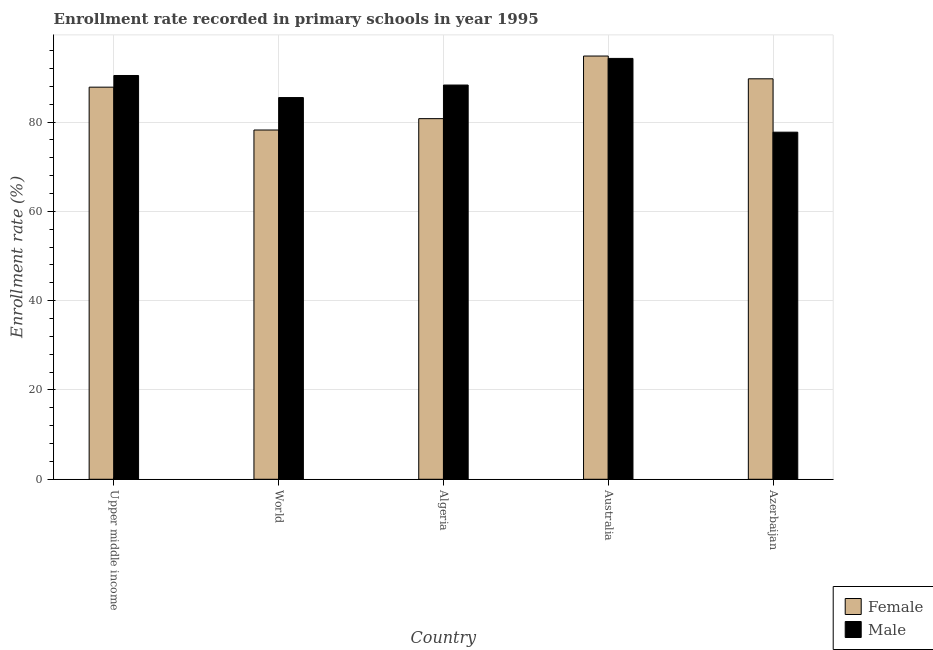How many different coloured bars are there?
Your answer should be very brief. 2. Are the number of bars per tick equal to the number of legend labels?
Give a very brief answer. Yes. Are the number of bars on each tick of the X-axis equal?
Your answer should be very brief. Yes. How many bars are there on the 4th tick from the left?
Ensure brevity in your answer.  2. How many bars are there on the 4th tick from the right?
Provide a succinct answer. 2. What is the label of the 5th group of bars from the left?
Ensure brevity in your answer.  Azerbaijan. In how many cases, is the number of bars for a given country not equal to the number of legend labels?
Ensure brevity in your answer.  0. What is the enrollment rate of female students in World?
Keep it short and to the point. 78.23. Across all countries, what is the maximum enrollment rate of female students?
Provide a short and direct response. 94.8. Across all countries, what is the minimum enrollment rate of female students?
Make the answer very short. 78.23. In which country was the enrollment rate of male students maximum?
Ensure brevity in your answer.  Australia. What is the total enrollment rate of male students in the graph?
Offer a terse response. 436.26. What is the difference between the enrollment rate of female students in Australia and that in Azerbaijan?
Ensure brevity in your answer.  5.1. What is the difference between the enrollment rate of male students in Australia and the enrollment rate of female students in Algeria?
Give a very brief answer. 13.49. What is the average enrollment rate of female students per country?
Give a very brief answer. 86.27. What is the difference between the enrollment rate of female students and enrollment rate of male students in Australia?
Provide a succinct answer. 0.53. In how many countries, is the enrollment rate of female students greater than 16 %?
Provide a succinct answer. 5. What is the ratio of the enrollment rate of male students in Azerbaijan to that in World?
Provide a succinct answer. 0.91. Is the enrollment rate of female students in Azerbaijan less than that in World?
Provide a succinct answer. No. What is the difference between the highest and the second highest enrollment rate of female students?
Your answer should be compact. 5.1. What is the difference between the highest and the lowest enrollment rate of male students?
Give a very brief answer. 16.52. What does the 2nd bar from the right in Upper middle income represents?
Ensure brevity in your answer.  Female. How many bars are there?
Give a very brief answer. 10. Are all the bars in the graph horizontal?
Offer a terse response. No. What is the difference between two consecutive major ticks on the Y-axis?
Keep it short and to the point. 20. Are the values on the major ticks of Y-axis written in scientific E-notation?
Your response must be concise. No. Does the graph contain any zero values?
Make the answer very short. No. Where does the legend appear in the graph?
Ensure brevity in your answer.  Bottom right. How many legend labels are there?
Keep it short and to the point. 2. How are the legend labels stacked?
Provide a succinct answer. Vertical. What is the title of the graph?
Your response must be concise. Enrollment rate recorded in primary schools in year 1995. Does "constant 2005 US$" appear as one of the legend labels in the graph?
Give a very brief answer. No. What is the label or title of the X-axis?
Provide a succinct answer. Country. What is the label or title of the Y-axis?
Offer a terse response. Enrollment rate (%). What is the Enrollment rate (%) of Female in Upper middle income?
Give a very brief answer. 87.83. What is the Enrollment rate (%) of Male in Upper middle income?
Keep it short and to the point. 90.44. What is the Enrollment rate (%) in Female in World?
Offer a very short reply. 78.23. What is the Enrollment rate (%) in Male in World?
Offer a terse response. 85.5. What is the Enrollment rate (%) of Female in Algeria?
Provide a succinct answer. 80.77. What is the Enrollment rate (%) in Male in Algeria?
Offer a terse response. 88.3. What is the Enrollment rate (%) of Female in Australia?
Give a very brief answer. 94.8. What is the Enrollment rate (%) in Male in Australia?
Your response must be concise. 94.27. What is the Enrollment rate (%) in Female in Azerbaijan?
Make the answer very short. 89.7. What is the Enrollment rate (%) of Male in Azerbaijan?
Your response must be concise. 77.74. Across all countries, what is the maximum Enrollment rate (%) of Female?
Your answer should be compact. 94.8. Across all countries, what is the maximum Enrollment rate (%) of Male?
Offer a very short reply. 94.27. Across all countries, what is the minimum Enrollment rate (%) of Female?
Your answer should be compact. 78.23. Across all countries, what is the minimum Enrollment rate (%) in Male?
Your answer should be very brief. 77.74. What is the total Enrollment rate (%) of Female in the graph?
Your response must be concise. 431.34. What is the total Enrollment rate (%) in Male in the graph?
Offer a very short reply. 436.26. What is the difference between the Enrollment rate (%) of Female in Upper middle income and that in World?
Offer a very short reply. 9.6. What is the difference between the Enrollment rate (%) of Male in Upper middle income and that in World?
Make the answer very short. 4.94. What is the difference between the Enrollment rate (%) of Female in Upper middle income and that in Algeria?
Your answer should be compact. 7.05. What is the difference between the Enrollment rate (%) of Male in Upper middle income and that in Algeria?
Give a very brief answer. 2.14. What is the difference between the Enrollment rate (%) in Female in Upper middle income and that in Australia?
Give a very brief answer. -6.97. What is the difference between the Enrollment rate (%) in Male in Upper middle income and that in Australia?
Make the answer very short. -3.83. What is the difference between the Enrollment rate (%) in Female in Upper middle income and that in Azerbaijan?
Make the answer very short. -1.87. What is the difference between the Enrollment rate (%) in Male in Upper middle income and that in Azerbaijan?
Your response must be concise. 12.7. What is the difference between the Enrollment rate (%) in Female in World and that in Algeria?
Your answer should be compact. -2.54. What is the difference between the Enrollment rate (%) in Male in World and that in Algeria?
Give a very brief answer. -2.8. What is the difference between the Enrollment rate (%) of Female in World and that in Australia?
Keep it short and to the point. -16.57. What is the difference between the Enrollment rate (%) in Male in World and that in Australia?
Your response must be concise. -8.77. What is the difference between the Enrollment rate (%) of Female in World and that in Azerbaijan?
Offer a terse response. -11.47. What is the difference between the Enrollment rate (%) in Male in World and that in Azerbaijan?
Ensure brevity in your answer.  7.76. What is the difference between the Enrollment rate (%) in Female in Algeria and that in Australia?
Ensure brevity in your answer.  -14.03. What is the difference between the Enrollment rate (%) of Male in Algeria and that in Australia?
Keep it short and to the point. -5.96. What is the difference between the Enrollment rate (%) in Female in Algeria and that in Azerbaijan?
Offer a terse response. -8.93. What is the difference between the Enrollment rate (%) of Male in Algeria and that in Azerbaijan?
Your answer should be very brief. 10.56. What is the difference between the Enrollment rate (%) of Female in Australia and that in Azerbaijan?
Make the answer very short. 5.1. What is the difference between the Enrollment rate (%) in Male in Australia and that in Azerbaijan?
Keep it short and to the point. 16.52. What is the difference between the Enrollment rate (%) in Female in Upper middle income and the Enrollment rate (%) in Male in World?
Offer a terse response. 2.33. What is the difference between the Enrollment rate (%) of Female in Upper middle income and the Enrollment rate (%) of Male in Algeria?
Offer a terse response. -0.48. What is the difference between the Enrollment rate (%) in Female in Upper middle income and the Enrollment rate (%) in Male in Australia?
Make the answer very short. -6.44. What is the difference between the Enrollment rate (%) in Female in Upper middle income and the Enrollment rate (%) in Male in Azerbaijan?
Ensure brevity in your answer.  10.08. What is the difference between the Enrollment rate (%) in Female in World and the Enrollment rate (%) in Male in Algeria?
Keep it short and to the point. -10.07. What is the difference between the Enrollment rate (%) in Female in World and the Enrollment rate (%) in Male in Australia?
Your answer should be compact. -16.04. What is the difference between the Enrollment rate (%) of Female in World and the Enrollment rate (%) of Male in Azerbaijan?
Your response must be concise. 0.49. What is the difference between the Enrollment rate (%) in Female in Algeria and the Enrollment rate (%) in Male in Australia?
Give a very brief answer. -13.49. What is the difference between the Enrollment rate (%) in Female in Algeria and the Enrollment rate (%) in Male in Azerbaijan?
Provide a succinct answer. 3.03. What is the difference between the Enrollment rate (%) in Female in Australia and the Enrollment rate (%) in Male in Azerbaijan?
Your answer should be very brief. 17.06. What is the average Enrollment rate (%) in Female per country?
Give a very brief answer. 86.27. What is the average Enrollment rate (%) in Male per country?
Offer a terse response. 87.25. What is the difference between the Enrollment rate (%) in Female and Enrollment rate (%) in Male in Upper middle income?
Give a very brief answer. -2.61. What is the difference between the Enrollment rate (%) in Female and Enrollment rate (%) in Male in World?
Give a very brief answer. -7.27. What is the difference between the Enrollment rate (%) of Female and Enrollment rate (%) of Male in Algeria?
Make the answer very short. -7.53. What is the difference between the Enrollment rate (%) in Female and Enrollment rate (%) in Male in Australia?
Give a very brief answer. 0.53. What is the difference between the Enrollment rate (%) in Female and Enrollment rate (%) in Male in Azerbaijan?
Provide a short and direct response. 11.96. What is the ratio of the Enrollment rate (%) in Female in Upper middle income to that in World?
Your answer should be very brief. 1.12. What is the ratio of the Enrollment rate (%) in Male in Upper middle income to that in World?
Make the answer very short. 1.06. What is the ratio of the Enrollment rate (%) of Female in Upper middle income to that in Algeria?
Provide a short and direct response. 1.09. What is the ratio of the Enrollment rate (%) in Male in Upper middle income to that in Algeria?
Your answer should be very brief. 1.02. What is the ratio of the Enrollment rate (%) in Female in Upper middle income to that in Australia?
Your answer should be compact. 0.93. What is the ratio of the Enrollment rate (%) in Male in Upper middle income to that in Australia?
Keep it short and to the point. 0.96. What is the ratio of the Enrollment rate (%) in Female in Upper middle income to that in Azerbaijan?
Ensure brevity in your answer.  0.98. What is the ratio of the Enrollment rate (%) in Male in Upper middle income to that in Azerbaijan?
Your answer should be compact. 1.16. What is the ratio of the Enrollment rate (%) of Female in World to that in Algeria?
Keep it short and to the point. 0.97. What is the ratio of the Enrollment rate (%) in Male in World to that in Algeria?
Ensure brevity in your answer.  0.97. What is the ratio of the Enrollment rate (%) in Female in World to that in Australia?
Provide a succinct answer. 0.83. What is the ratio of the Enrollment rate (%) in Male in World to that in Australia?
Offer a very short reply. 0.91. What is the ratio of the Enrollment rate (%) of Female in World to that in Azerbaijan?
Your answer should be very brief. 0.87. What is the ratio of the Enrollment rate (%) in Male in World to that in Azerbaijan?
Make the answer very short. 1.1. What is the ratio of the Enrollment rate (%) of Female in Algeria to that in Australia?
Ensure brevity in your answer.  0.85. What is the ratio of the Enrollment rate (%) of Male in Algeria to that in Australia?
Provide a short and direct response. 0.94. What is the ratio of the Enrollment rate (%) in Female in Algeria to that in Azerbaijan?
Give a very brief answer. 0.9. What is the ratio of the Enrollment rate (%) in Male in Algeria to that in Azerbaijan?
Your response must be concise. 1.14. What is the ratio of the Enrollment rate (%) of Female in Australia to that in Azerbaijan?
Keep it short and to the point. 1.06. What is the ratio of the Enrollment rate (%) in Male in Australia to that in Azerbaijan?
Ensure brevity in your answer.  1.21. What is the difference between the highest and the second highest Enrollment rate (%) in Female?
Make the answer very short. 5.1. What is the difference between the highest and the second highest Enrollment rate (%) in Male?
Your response must be concise. 3.83. What is the difference between the highest and the lowest Enrollment rate (%) of Female?
Offer a terse response. 16.57. What is the difference between the highest and the lowest Enrollment rate (%) of Male?
Offer a very short reply. 16.52. 